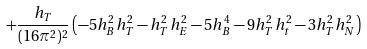<formula> <loc_0><loc_0><loc_500><loc_500>+ \frac { h _ { T } } { ( 1 6 \pi ^ { 2 } ) ^ { 2 } } \left ( - 5 h _ { B } ^ { 2 } h _ { T } ^ { 2 } - h _ { T } ^ { 2 } h _ { E } ^ { 2 } - 5 h _ { B } ^ { 4 } - 9 h _ { T } ^ { 2 } h _ { t } ^ { 2 } - 3 h _ { T } ^ { 2 } h _ { N } ^ { 2 } \right )</formula> 